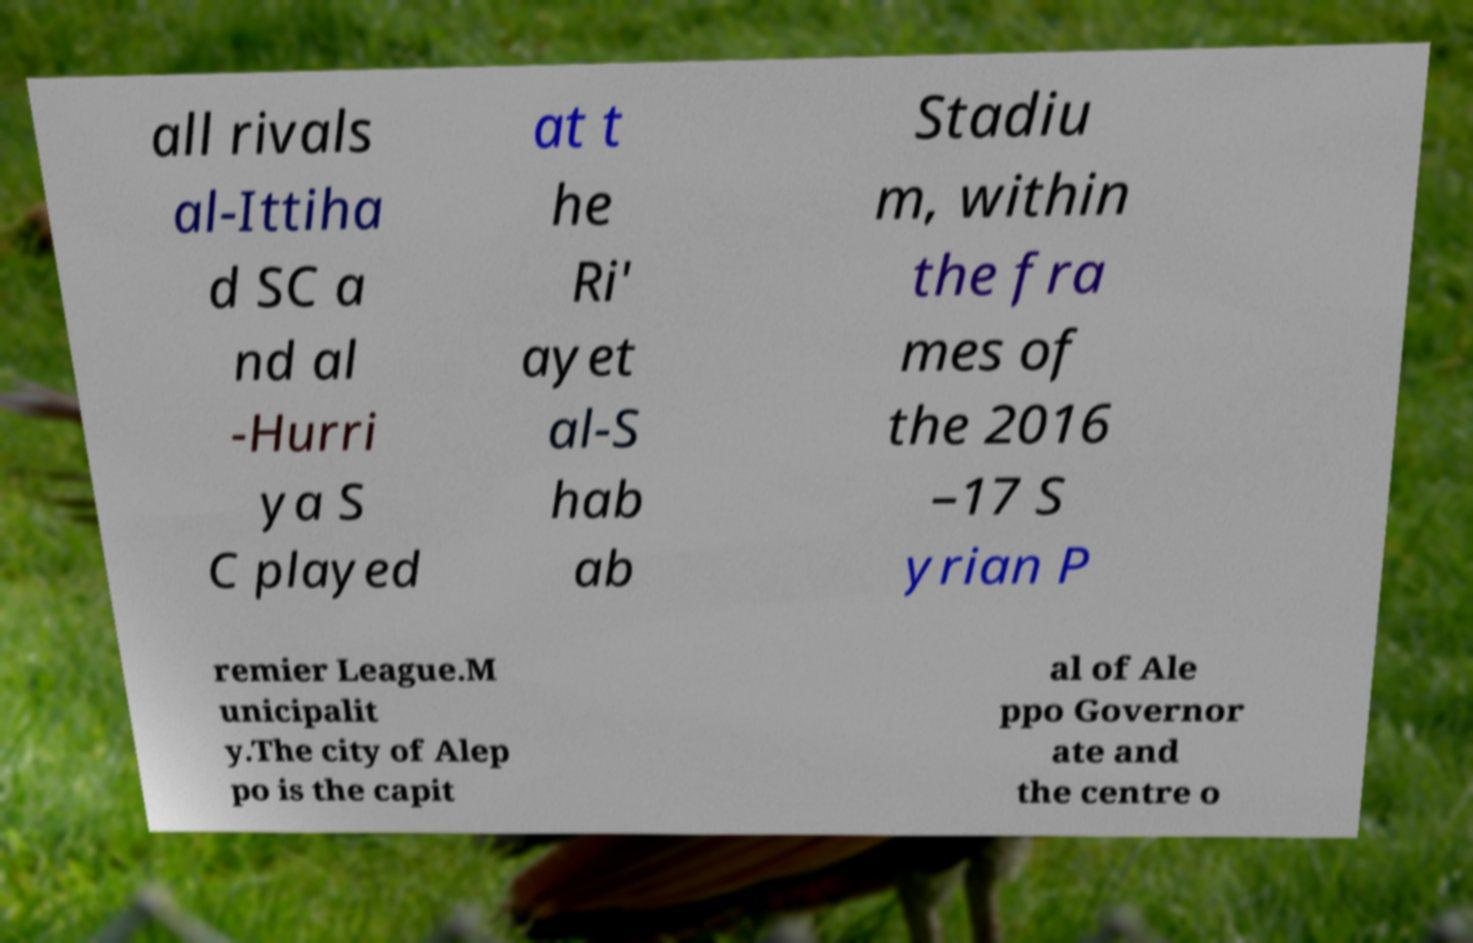Can you accurately transcribe the text from the provided image for me? all rivals al-Ittiha d SC a nd al -Hurri ya S C played at t he Ri' ayet al-S hab ab Stadiu m, within the fra mes of the 2016 –17 S yrian P remier League.M unicipalit y.The city of Alep po is the capit al of Ale ppo Governor ate and the centre o 